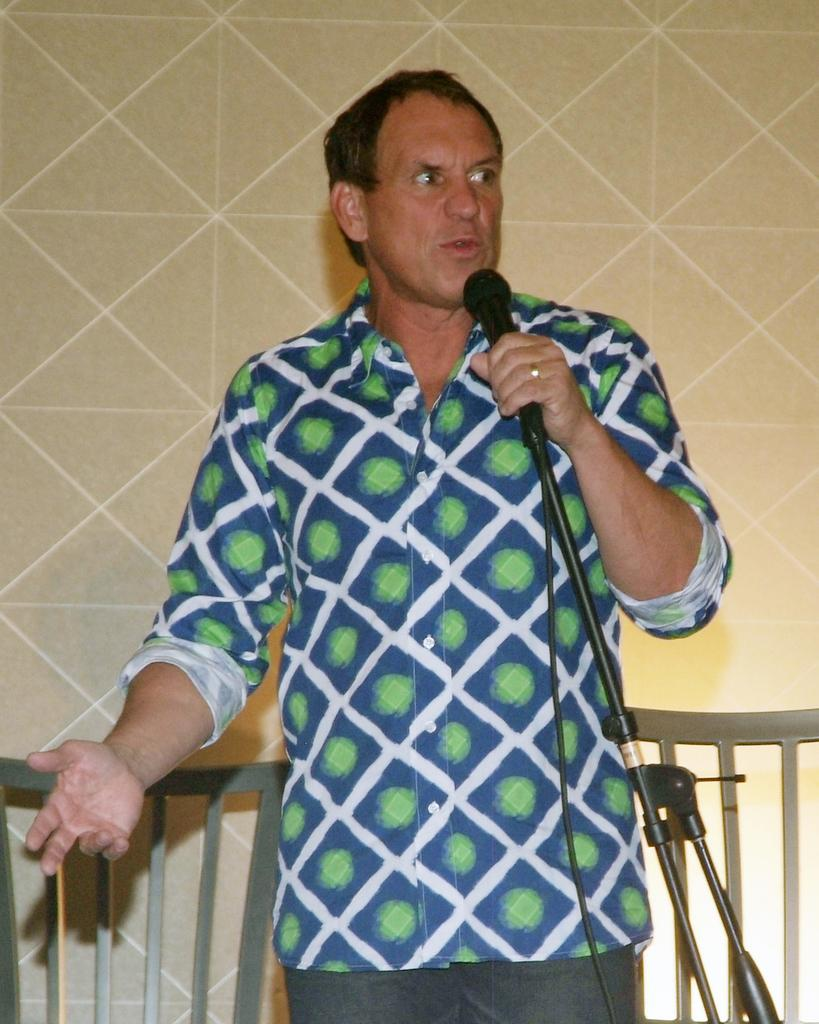What is the person in the image doing? The person is standing and holding a microphone. What is the purpose of the microphone with a stand in the image? The microphone with a stand is likely used for amplifying the person's voice. What can be seen in the background of the image? There is a wall and chairs in the background of the image. What type of coal is being used to fuel the person's performance in the image? There is no coal present in the image, and the person's performance is not fueled by coal. 